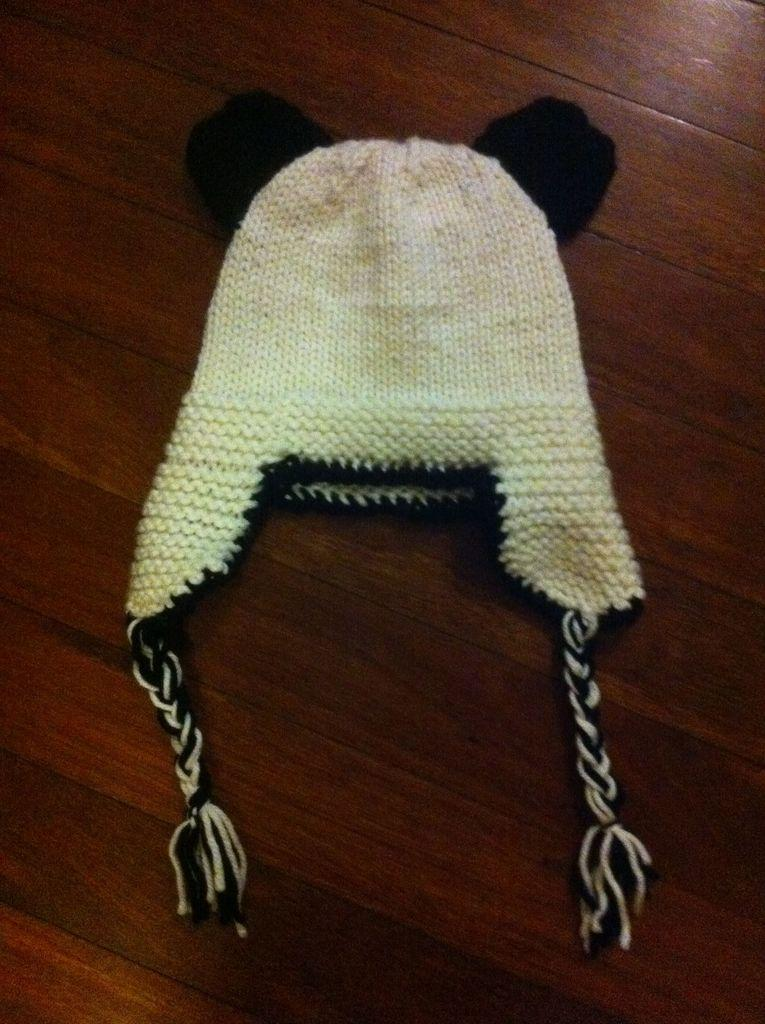What object is present in the image? There is a cap in the image. Where is the cap located? The cap is on a wooden surface. What date is marked on the calendar in the image? There is no calendar present in the image, so it is not possible to answer that question. 